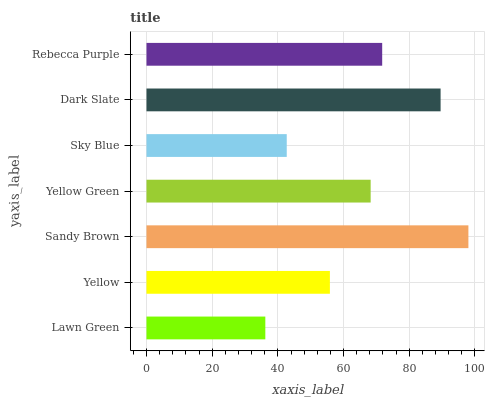Is Lawn Green the minimum?
Answer yes or no. Yes. Is Sandy Brown the maximum?
Answer yes or no. Yes. Is Yellow the minimum?
Answer yes or no. No. Is Yellow the maximum?
Answer yes or no. No. Is Yellow greater than Lawn Green?
Answer yes or no. Yes. Is Lawn Green less than Yellow?
Answer yes or no. Yes. Is Lawn Green greater than Yellow?
Answer yes or no. No. Is Yellow less than Lawn Green?
Answer yes or no. No. Is Yellow Green the high median?
Answer yes or no. Yes. Is Yellow Green the low median?
Answer yes or no. Yes. Is Sky Blue the high median?
Answer yes or no. No. Is Lawn Green the low median?
Answer yes or no. No. 